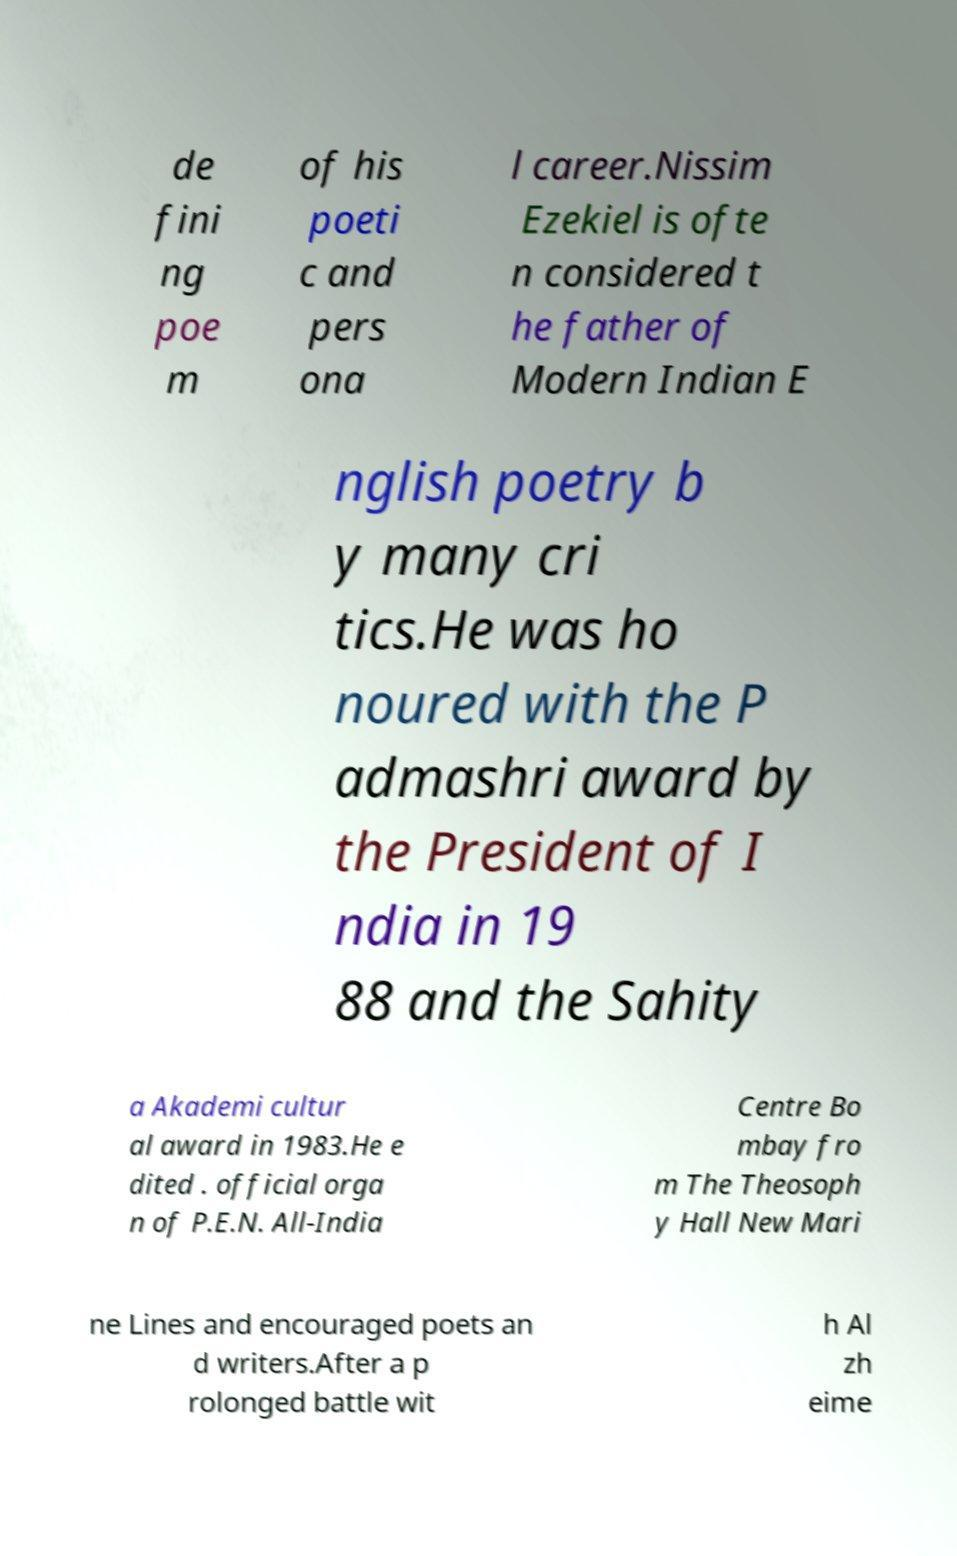Can you read and provide the text displayed in the image?This photo seems to have some interesting text. Can you extract and type it out for me? de fini ng poe m of his poeti c and pers ona l career.Nissim Ezekiel is ofte n considered t he father of Modern Indian E nglish poetry b y many cri tics.He was ho noured with the P admashri award by the President of I ndia in 19 88 and the Sahity a Akademi cultur al award in 1983.He e dited . official orga n of P.E.N. All-India Centre Bo mbay fro m The Theosoph y Hall New Mari ne Lines and encouraged poets an d writers.After a p rolonged battle wit h Al zh eime 